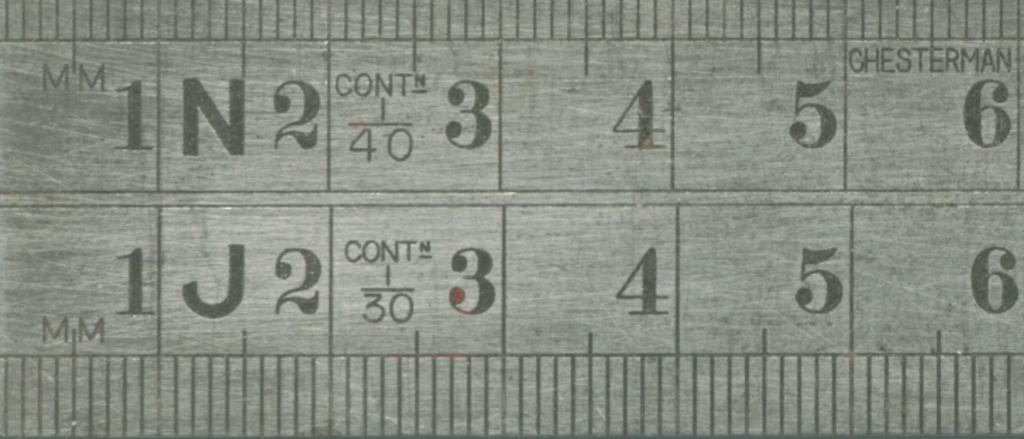<image>
Summarize the visual content of the image. Close up of a metal millimeter ruler showing zero through six. 